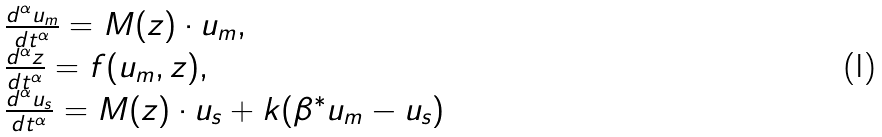<formula> <loc_0><loc_0><loc_500><loc_500>\begin{array} { l } \frac { d ^ { \alpha } u _ { m } } { d t ^ { \alpha } } = M ( z ) \cdot { u } _ { m } , \\ \frac { d ^ { \alpha } z } { d t ^ { \alpha } } = f ( u _ { m } , z ) , \\ \frac { d ^ { \alpha } u _ { s } } { d t ^ { \alpha } } = M ( z ) \cdot u _ { s } + k ( \beta ^ { * } u _ { m } - u _ { s } ) \end{array}</formula> 